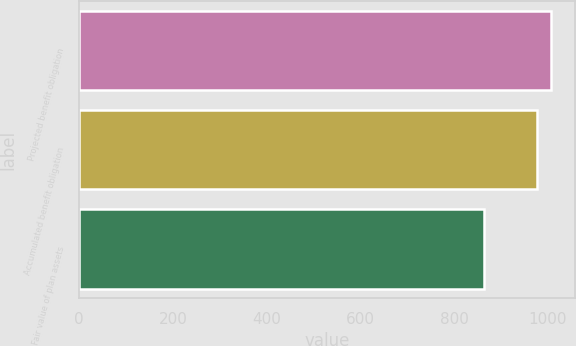<chart> <loc_0><loc_0><loc_500><loc_500><bar_chart><fcel>Projected benefit obligation<fcel>Accumulated benefit obligation<fcel>Fair value of plan assets<nl><fcel>1007<fcel>976<fcel>864<nl></chart> 